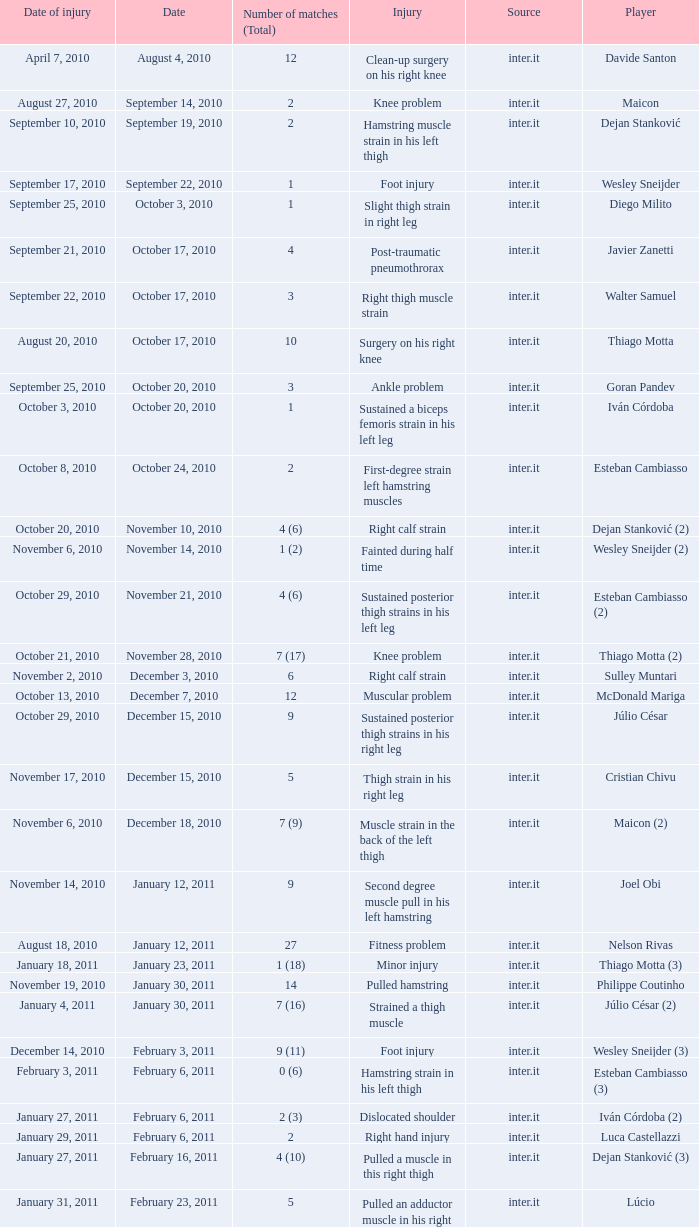How many times was the date october 3, 2010? 1.0. 